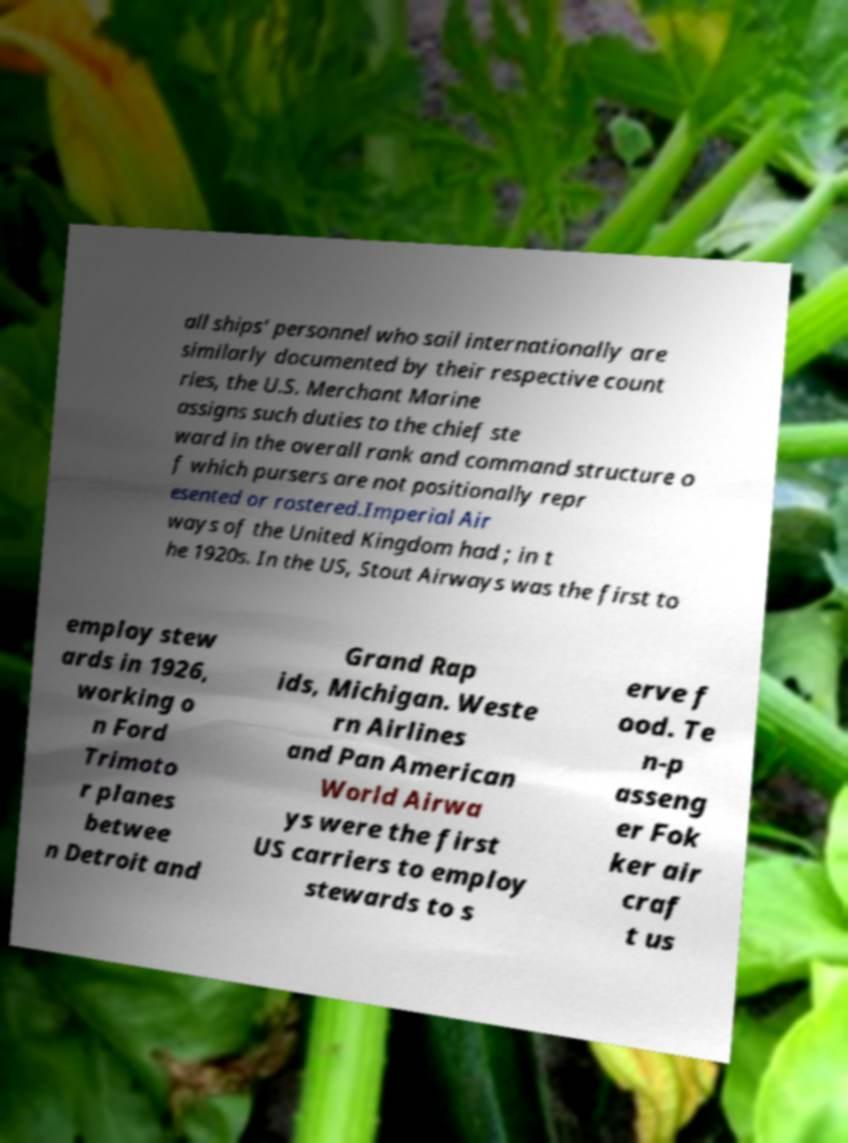For documentation purposes, I need the text within this image transcribed. Could you provide that? all ships' personnel who sail internationally are similarly documented by their respective count ries, the U.S. Merchant Marine assigns such duties to the chief ste ward in the overall rank and command structure o f which pursers are not positionally repr esented or rostered.Imperial Air ways of the United Kingdom had ; in t he 1920s. In the US, Stout Airways was the first to employ stew ards in 1926, working o n Ford Trimoto r planes betwee n Detroit and Grand Rap ids, Michigan. Weste rn Airlines and Pan American World Airwa ys were the first US carriers to employ stewards to s erve f ood. Te n-p asseng er Fok ker air craf t us 